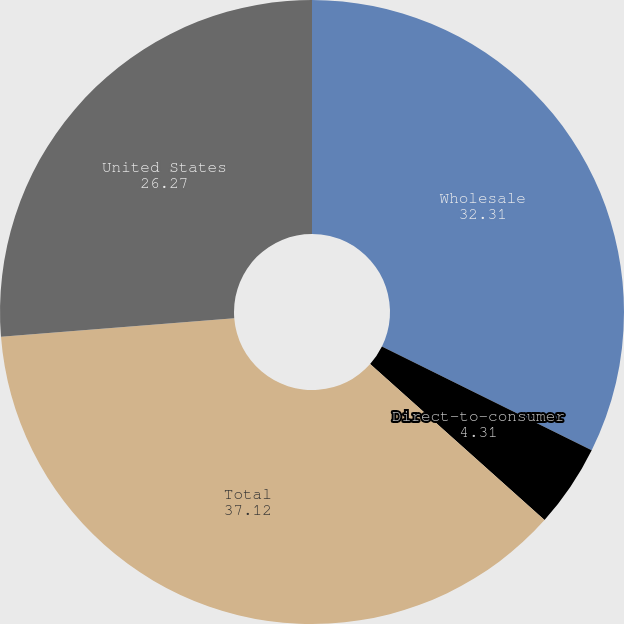Convert chart to OTSL. <chart><loc_0><loc_0><loc_500><loc_500><pie_chart><fcel>Wholesale<fcel>Direct-to-consumer<fcel>Total<fcel>United States<nl><fcel>32.31%<fcel>4.31%<fcel>37.12%<fcel>26.27%<nl></chart> 